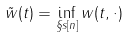Convert formula to latex. <formula><loc_0><loc_0><loc_500><loc_500>\tilde { w } ( t ) = \inf _ { \S s [ n ] } w ( t , \cdot )</formula> 